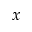<formula> <loc_0><loc_0><loc_500><loc_500>x</formula> 